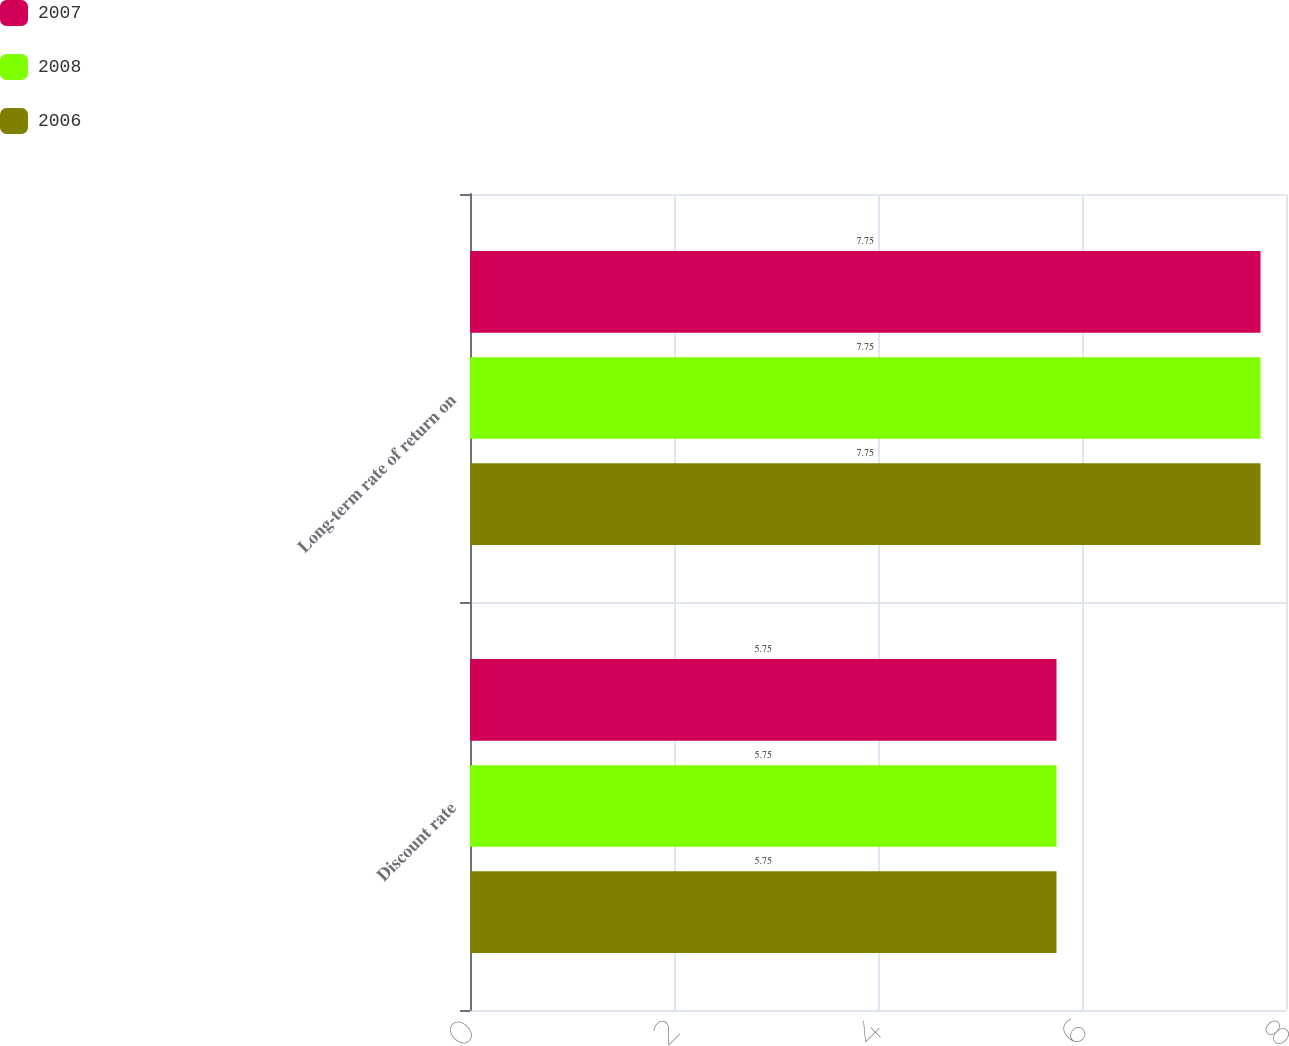Convert chart to OTSL. <chart><loc_0><loc_0><loc_500><loc_500><stacked_bar_chart><ecel><fcel>Discount rate<fcel>Long-term rate of return on<nl><fcel>2007<fcel>5.75<fcel>7.75<nl><fcel>2008<fcel>5.75<fcel>7.75<nl><fcel>2006<fcel>5.75<fcel>7.75<nl></chart> 